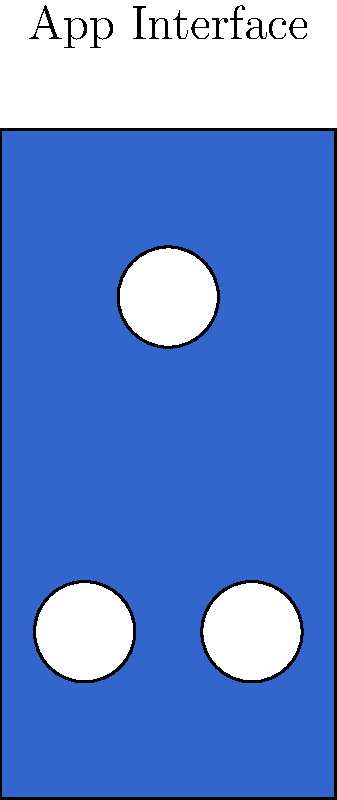Analyze the color scheme of this mobile app interface. What emotional response is this design likely to evoke in users, and how might it impact the overall user experience? To analyze the color scheme and its emotional impact:

1. Identify the main color: The primary color used is a medium to dark blue (rgb(0.2,0.4,0.8)).

2. Understand color psychology:
   - Blue is often associated with trust, stability, and calmness.
   - Darker shades of blue can convey professionalism and reliability.

3. Consider the contrast:
   - The white circular elements create a high contrast against the blue background.
   - This contrast can improve readability and draw attention to key interface elements.

4. Evaluate the overall composition:
   - The simple, clean design with minimal colors creates a sense of order and clarity.
   - The symmetrical arrangement of white circles adds balance to the design.

5. Assess the emotional impact:
   - The combination of blue and white evokes a sense of trust and professionalism.
   - The calm nature of blue can make users feel at ease while using the app.
   - The clean, uncluttered design may reduce cognitive load and stress for users.

6. Consider the user experience implications:
   - The color scheme and layout suggest a focus on functionality and ease of use.
   - Users may perceive the app as reliable and straightforward, potentially increasing their confidence in using it.
   - The calming effect of blue could be beneficial for apps related to productivity, finance, or other areas where user trust is crucial.

Given these factors, the color scheme is likely to evoke a sense of trust, calmness, and professionalism, positively impacting the user experience by making users feel confident and at ease while using the app.
Answer: Trust, calmness, and professionalism; positive impact on user confidence and ease of use. 